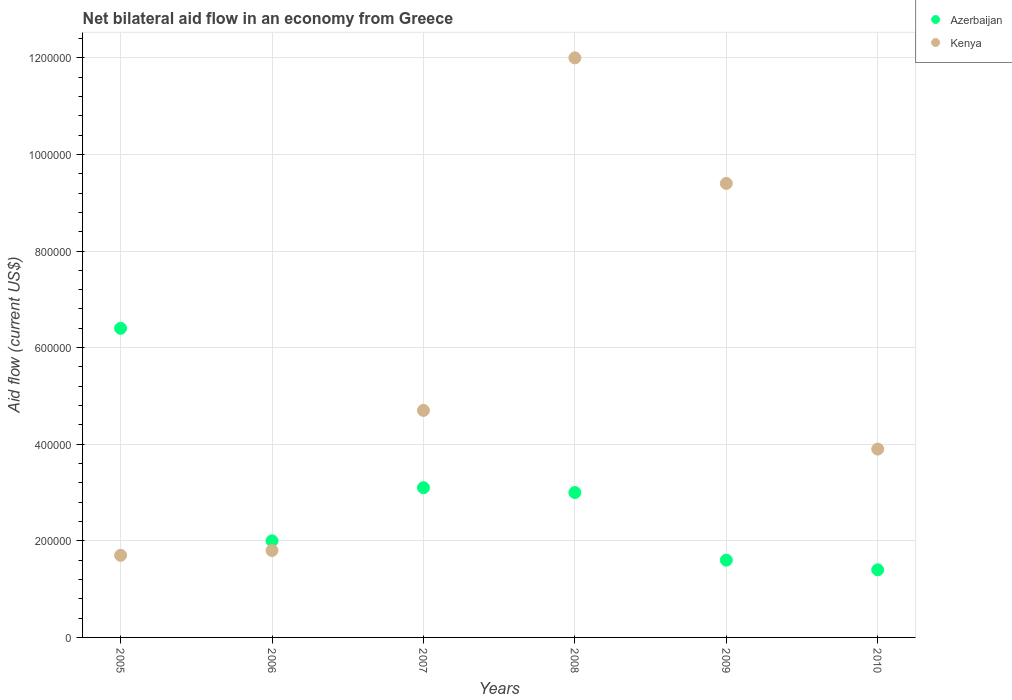Is the number of dotlines equal to the number of legend labels?
Provide a short and direct response. Yes. What is the net bilateral aid flow in Azerbaijan in 2010?
Keep it short and to the point. 1.40e+05. Across all years, what is the maximum net bilateral aid flow in Kenya?
Offer a very short reply. 1.20e+06. In which year was the net bilateral aid flow in Azerbaijan maximum?
Provide a succinct answer. 2005. In which year was the net bilateral aid flow in Azerbaijan minimum?
Offer a terse response. 2010. What is the total net bilateral aid flow in Kenya in the graph?
Your answer should be very brief. 3.35e+06. What is the average net bilateral aid flow in Azerbaijan per year?
Your answer should be very brief. 2.92e+05. In the year 2008, what is the difference between the net bilateral aid flow in Azerbaijan and net bilateral aid flow in Kenya?
Your answer should be very brief. -9.00e+05. What is the ratio of the net bilateral aid flow in Kenya in 2005 to that in 2007?
Keep it short and to the point. 0.36. Is the net bilateral aid flow in Azerbaijan in 2005 less than that in 2006?
Keep it short and to the point. No. Is the difference between the net bilateral aid flow in Azerbaijan in 2007 and 2008 greater than the difference between the net bilateral aid flow in Kenya in 2007 and 2008?
Offer a very short reply. Yes. What is the difference between the highest and the lowest net bilateral aid flow in Azerbaijan?
Offer a very short reply. 5.00e+05. Is the sum of the net bilateral aid flow in Kenya in 2005 and 2009 greater than the maximum net bilateral aid flow in Azerbaijan across all years?
Offer a very short reply. Yes. Does the net bilateral aid flow in Azerbaijan monotonically increase over the years?
Give a very brief answer. No. Is the net bilateral aid flow in Azerbaijan strictly less than the net bilateral aid flow in Kenya over the years?
Your answer should be very brief. No. How many dotlines are there?
Make the answer very short. 2. How many years are there in the graph?
Keep it short and to the point. 6. What is the difference between two consecutive major ticks on the Y-axis?
Your answer should be very brief. 2.00e+05. Where does the legend appear in the graph?
Offer a terse response. Top right. How are the legend labels stacked?
Ensure brevity in your answer.  Vertical. What is the title of the graph?
Your answer should be very brief. Net bilateral aid flow in an economy from Greece. Does "North America" appear as one of the legend labels in the graph?
Your answer should be compact. No. What is the label or title of the Y-axis?
Ensure brevity in your answer.  Aid flow (current US$). What is the Aid flow (current US$) of Azerbaijan in 2005?
Provide a short and direct response. 6.40e+05. What is the Aid flow (current US$) of Azerbaijan in 2007?
Give a very brief answer. 3.10e+05. What is the Aid flow (current US$) of Kenya in 2008?
Your response must be concise. 1.20e+06. What is the Aid flow (current US$) in Azerbaijan in 2009?
Ensure brevity in your answer.  1.60e+05. What is the Aid flow (current US$) of Kenya in 2009?
Your answer should be very brief. 9.40e+05. What is the Aid flow (current US$) of Azerbaijan in 2010?
Make the answer very short. 1.40e+05. Across all years, what is the maximum Aid flow (current US$) of Azerbaijan?
Your answer should be very brief. 6.40e+05. Across all years, what is the maximum Aid flow (current US$) of Kenya?
Your response must be concise. 1.20e+06. What is the total Aid flow (current US$) in Azerbaijan in the graph?
Provide a succinct answer. 1.75e+06. What is the total Aid flow (current US$) in Kenya in the graph?
Provide a succinct answer. 3.35e+06. What is the difference between the Aid flow (current US$) in Kenya in 2005 and that in 2007?
Provide a short and direct response. -3.00e+05. What is the difference between the Aid flow (current US$) of Azerbaijan in 2005 and that in 2008?
Keep it short and to the point. 3.40e+05. What is the difference between the Aid flow (current US$) of Kenya in 2005 and that in 2008?
Give a very brief answer. -1.03e+06. What is the difference between the Aid flow (current US$) of Azerbaijan in 2005 and that in 2009?
Your answer should be compact. 4.80e+05. What is the difference between the Aid flow (current US$) in Kenya in 2005 and that in 2009?
Offer a very short reply. -7.70e+05. What is the difference between the Aid flow (current US$) in Kenya in 2006 and that in 2007?
Provide a succinct answer. -2.90e+05. What is the difference between the Aid flow (current US$) in Azerbaijan in 2006 and that in 2008?
Provide a short and direct response. -1.00e+05. What is the difference between the Aid flow (current US$) in Kenya in 2006 and that in 2008?
Offer a very short reply. -1.02e+06. What is the difference between the Aid flow (current US$) in Azerbaijan in 2006 and that in 2009?
Make the answer very short. 4.00e+04. What is the difference between the Aid flow (current US$) of Kenya in 2006 and that in 2009?
Ensure brevity in your answer.  -7.60e+05. What is the difference between the Aid flow (current US$) of Azerbaijan in 2006 and that in 2010?
Your response must be concise. 6.00e+04. What is the difference between the Aid flow (current US$) of Kenya in 2006 and that in 2010?
Ensure brevity in your answer.  -2.10e+05. What is the difference between the Aid flow (current US$) in Azerbaijan in 2007 and that in 2008?
Your answer should be very brief. 10000. What is the difference between the Aid flow (current US$) in Kenya in 2007 and that in 2008?
Make the answer very short. -7.30e+05. What is the difference between the Aid flow (current US$) of Azerbaijan in 2007 and that in 2009?
Give a very brief answer. 1.50e+05. What is the difference between the Aid flow (current US$) of Kenya in 2007 and that in 2009?
Keep it short and to the point. -4.70e+05. What is the difference between the Aid flow (current US$) in Azerbaijan in 2007 and that in 2010?
Make the answer very short. 1.70e+05. What is the difference between the Aid flow (current US$) of Kenya in 2007 and that in 2010?
Provide a short and direct response. 8.00e+04. What is the difference between the Aid flow (current US$) in Kenya in 2008 and that in 2009?
Provide a succinct answer. 2.60e+05. What is the difference between the Aid flow (current US$) of Azerbaijan in 2008 and that in 2010?
Provide a short and direct response. 1.60e+05. What is the difference between the Aid flow (current US$) in Kenya in 2008 and that in 2010?
Your response must be concise. 8.10e+05. What is the difference between the Aid flow (current US$) of Azerbaijan in 2009 and that in 2010?
Your answer should be compact. 2.00e+04. What is the difference between the Aid flow (current US$) of Azerbaijan in 2005 and the Aid flow (current US$) of Kenya in 2008?
Keep it short and to the point. -5.60e+05. What is the difference between the Aid flow (current US$) in Azerbaijan in 2005 and the Aid flow (current US$) in Kenya in 2009?
Give a very brief answer. -3.00e+05. What is the difference between the Aid flow (current US$) of Azerbaijan in 2006 and the Aid flow (current US$) of Kenya in 2008?
Make the answer very short. -1.00e+06. What is the difference between the Aid flow (current US$) of Azerbaijan in 2006 and the Aid flow (current US$) of Kenya in 2009?
Your response must be concise. -7.40e+05. What is the difference between the Aid flow (current US$) of Azerbaijan in 2007 and the Aid flow (current US$) of Kenya in 2008?
Your response must be concise. -8.90e+05. What is the difference between the Aid flow (current US$) of Azerbaijan in 2007 and the Aid flow (current US$) of Kenya in 2009?
Your response must be concise. -6.30e+05. What is the difference between the Aid flow (current US$) in Azerbaijan in 2008 and the Aid flow (current US$) in Kenya in 2009?
Provide a succinct answer. -6.40e+05. What is the difference between the Aid flow (current US$) in Azerbaijan in 2009 and the Aid flow (current US$) in Kenya in 2010?
Make the answer very short. -2.30e+05. What is the average Aid flow (current US$) of Azerbaijan per year?
Ensure brevity in your answer.  2.92e+05. What is the average Aid flow (current US$) of Kenya per year?
Your response must be concise. 5.58e+05. In the year 2005, what is the difference between the Aid flow (current US$) of Azerbaijan and Aid flow (current US$) of Kenya?
Your answer should be very brief. 4.70e+05. In the year 2008, what is the difference between the Aid flow (current US$) of Azerbaijan and Aid flow (current US$) of Kenya?
Ensure brevity in your answer.  -9.00e+05. In the year 2009, what is the difference between the Aid flow (current US$) of Azerbaijan and Aid flow (current US$) of Kenya?
Ensure brevity in your answer.  -7.80e+05. What is the ratio of the Aid flow (current US$) in Azerbaijan in 2005 to that in 2006?
Your response must be concise. 3.2. What is the ratio of the Aid flow (current US$) of Kenya in 2005 to that in 2006?
Your answer should be very brief. 0.94. What is the ratio of the Aid flow (current US$) in Azerbaijan in 2005 to that in 2007?
Offer a terse response. 2.06. What is the ratio of the Aid flow (current US$) of Kenya in 2005 to that in 2007?
Offer a very short reply. 0.36. What is the ratio of the Aid flow (current US$) of Azerbaijan in 2005 to that in 2008?
Provide a short and direct response. 2.13. What is the ratio of the Aid flow (current US$) of Kenya in 2005 to that in 2008?
Provide a short and direct response. 0.14. What is the ratio of the Aid flow (current US$) in Azerbaijan in 2005 to that in 2009?
Give a very brief answer. 4. What is the ratio of the Aid flow (current US$) of Kenya in 2005 to that in 2009?
Your response must be concise. 0.18. What is the ratio of the Aid flow (current US$) in Azerbaijan in 2005 to that in 2010?
Your response must be concise. 4.57. What is the ratio of the Aid flow (current US$) of Kenya in 2005 to that in 2010?
Your response must be concise. 0.44. What is the ratio of the Aid flow (current US$) in Azerbaijan in 2006 to that in 2007?
Provide a short and direct response. 0.65. What is the ratio of the Aid flow (current US$) of Kenya in 2006 to that in 2007?
Provide a succinct answer. 0.38. What is the ratio of the Aid flow (current US$) of Azerbaijan in 2006 to that in 2008?
Ensure brevity in your answer.  0.67. What is the ratio of the Aid flow (current US$) of Azerbaijan in 2006 to that in 2009?
Provide a succinct answer. 1.25. What is the ratio of the Aid flow (current US$) of Kenya in 2006 to that in 2009?
Ensure brevity in your answer.  0.19. What is the ratio of the Aid flow (current US$) in Azerbaijan in 2006 to that in 2010?
Provide a succinct answer. 1.43. What is the ratio of the Aid flow (current US$) of Kenya in 2006 to that in 2010?
Give a very brief answer. 0.46. What is the ratio of the Aid flow (current US$) in Kenya in 2007 to that in 2008?
Provide a succinct answer. 0.39. What is the ratio of the Aid flow (current US$) of Azerbaijan in 2007 to that in 2009?
Your answer should be very brief. 1.94. What is the ratio of the Aid flow (current US$) of Azerbaijan in 2007 to that in 2010?
Offer a terse response. 2.21. What is the ratio of the Aid flow (current US$) in Kenya in 2007 to that in 2010?
Make the answer very short. 1.21. What is the ratio of the Aid flow (current US$) of Azerbaijan in 2008 to that in 2009?
Provide a short and direct response. 1.88. What is the ratio of the Aid flow (current US$) of Kenya in 2008 to that in 2009?
Provide a succinct answer. 1.28. What is the ratio of the Aid flow (current US$) in Azerbaijan in 2008 to that in 2010?
Offer a very short reply. 2.14. What is the ratio of the Aid flow (current US$) in Kenya in 2008 to that in 2010?
Give a very brief answer. 3.08. What is the ratio of the Aid flow (current US$) in Kenya in 2009 to that in 2010?
Your response must be concise. 2.41. What is the difference between the highest and the second highest Aid flow (current US$) in Azerbaijan?
Offer a terse response. 3.30e+05. What is the difference between the highest and the lowest Aid flow (current US$) in Kenya?
Keep it short and to the point. 1.03e+06. 